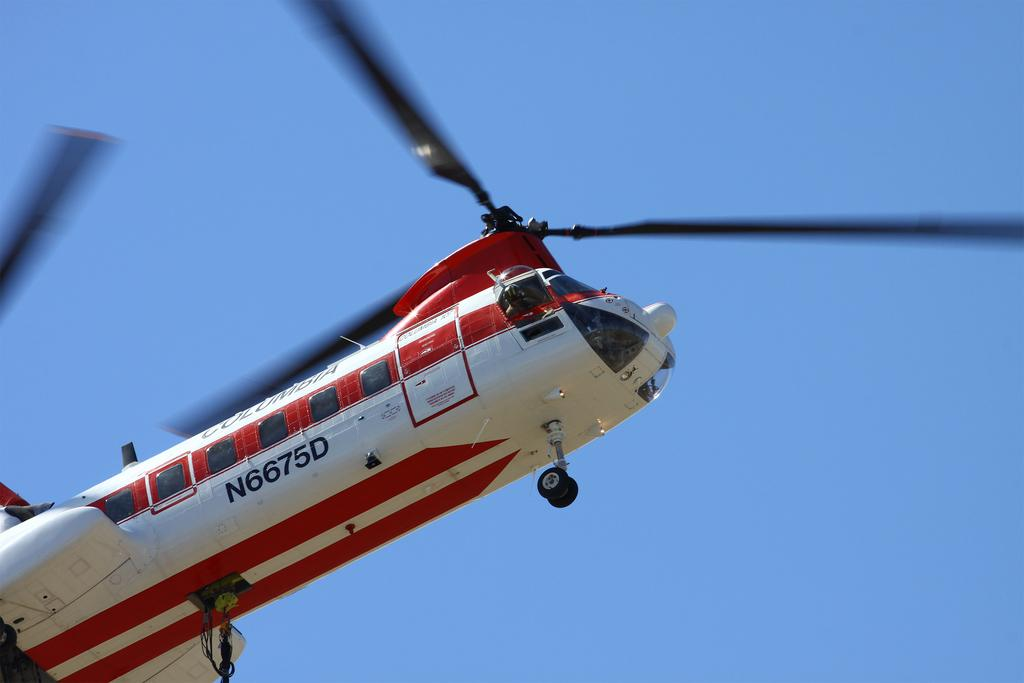What is the main subject of the picture? The main subject of the picture is an airplane. What is the airplane doing in the image? The airplane is flying. Can you tell if there are any passengers inside the airplane? Yes, there is a person inside the airplane. What can be seen in the background of the image? The sky is visible in the background of the image. What type of camera is being used by the person inside the airplane to take pictures of the sky? There is no camera mentioned or visible in the image, and we cannot assume that the person inside the airplane is taking pictures. How many quills are visible in the image? There are no quills present in the image. 